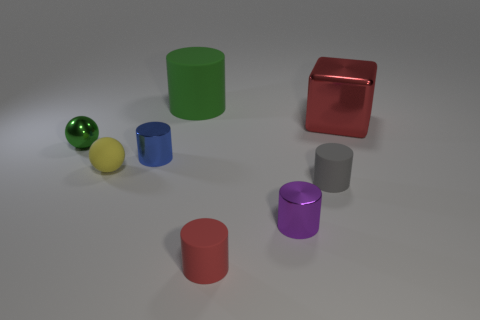There is a blue cylinder on the left side of the large thing on the left side of the large metal object; how big is it?
Offer a terse response. Small. The purple object is what shape?
Your response must be concise. Cylinder. There is a object that is on the right side of the gray cylinder; what is its material?
Give a very brief answer. Metal. There is a tiny metal cylinder in front of the blue cylinder that is left of the tiny rubber cylinder right of the purple cylinder; what color is it?
Offer a terse response. Purple. There is a matte sphere that is the same size as the shiny sphere; what is its color?
Your answer should be very brief. Yellow. What number of rubber objects are large green cylinders or big red objects?
Keep it short and to the point. 1. What color is the tiny ball that is the same material as the big green thing?
Keep it short and to the point. Yellow. What is the material of the large thing that is right of the small metallic object on the right side of the large cylinder?
Offer a very short reply. Metal. What number of objects are either big things on the right side of the red matte thing or metal cylinders that are right of the big green matte object?
Keep it short and to the point. 2. What is the size of the red thing on the left side of the cube to the right of the cylinder behind the small green metal thing?
Offer a very short reply. Small. 